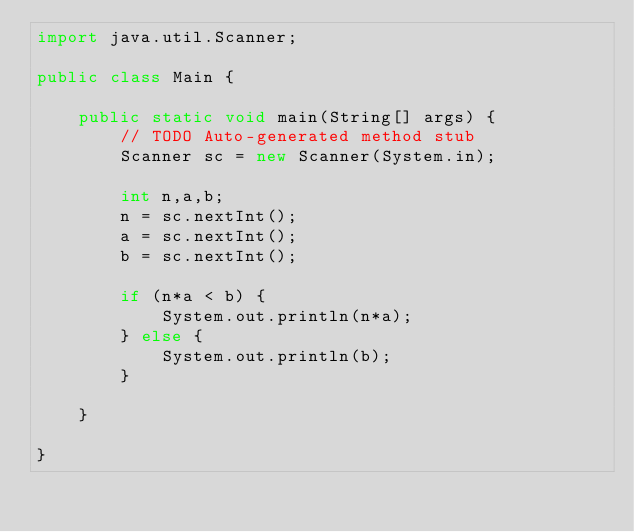<code> <loc_0><loc_0><loc_500><loc_500><_Java_>import java.util.Scanner;

public class Main {

	public static void main(String[] args) {
		// TODO Auto-generated method stub
		Scanner sc = new Scanner(System.in);
		
		int n,a,b;
		n = sc.nextInt();
		a = sc.nextInt();
		b = sc.nextInt();
		
		if (n*a < b) {
			System.out.println(n*a);
		} else {
			System.out.println(b);
		}

	}

}</code> 